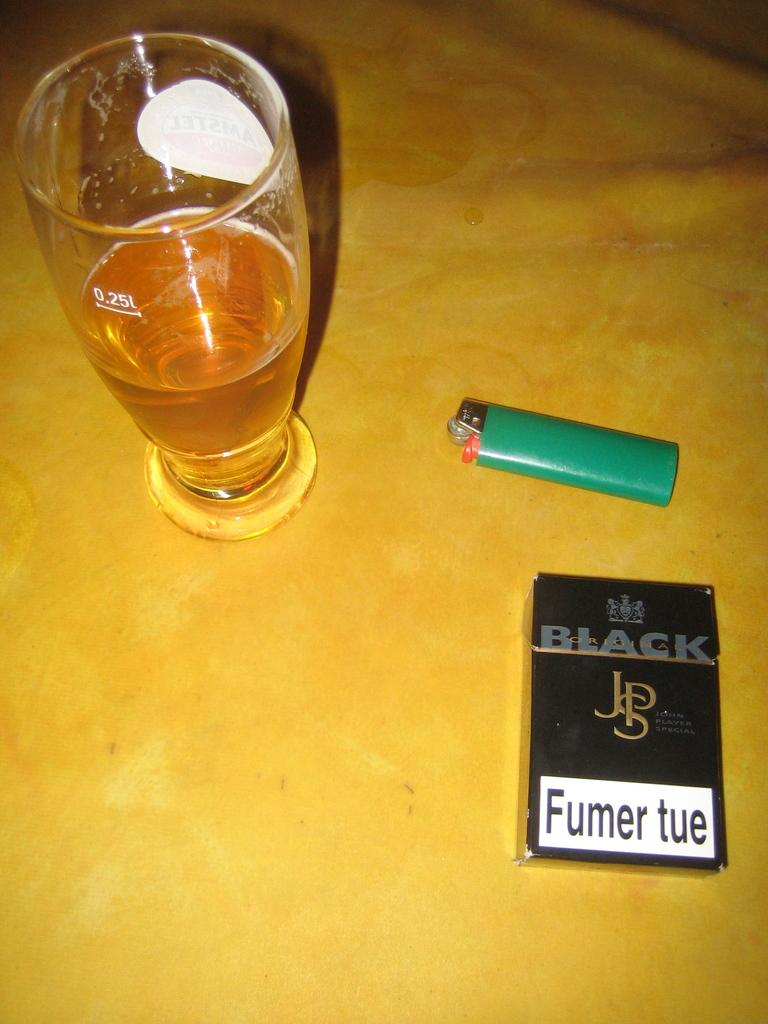<image>
Share a concise interpretation of the image provided. The cigarette packet beside the beer is from Black. 